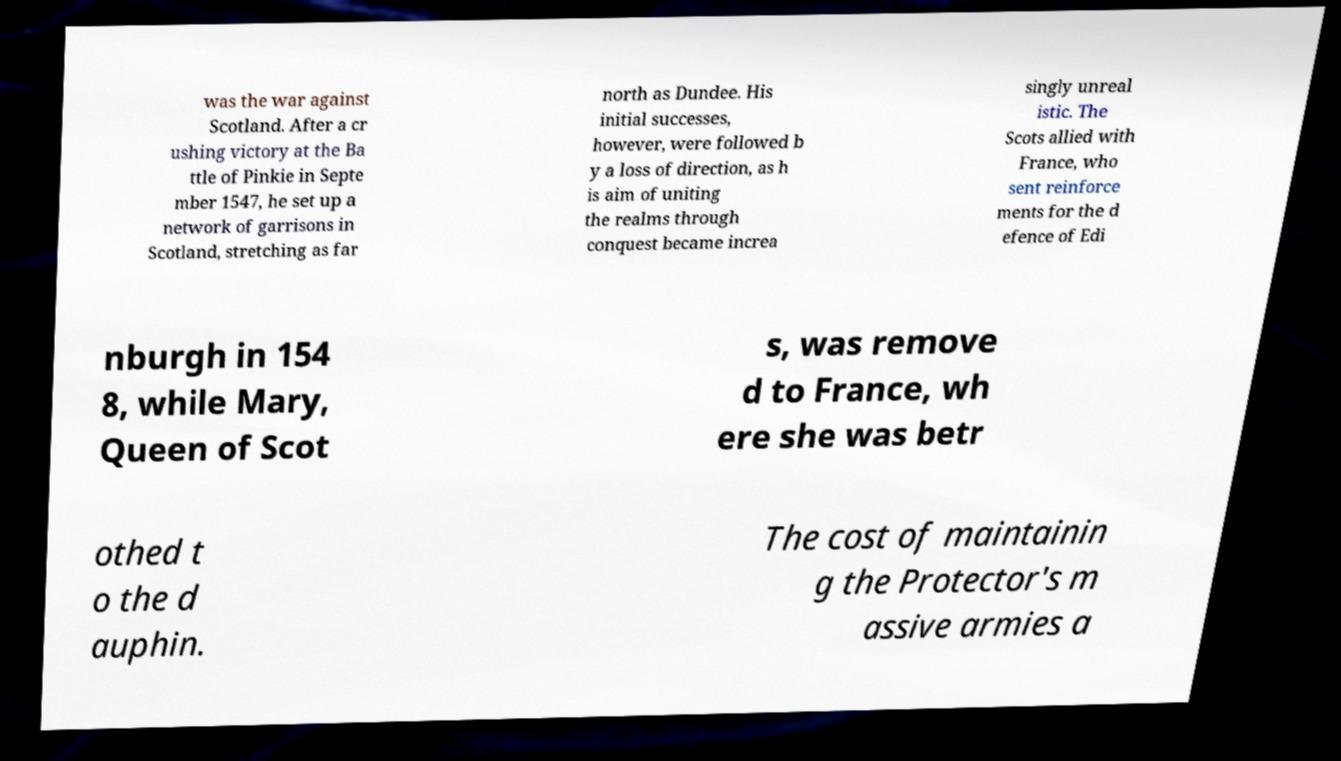Can you read and provide the text displayed in the image?This photo seems to have some interesting text. Can you extract and type it out for me? was the war against Scotland. After a cr ushing victory at the Ba ttle of Pinkie in Septe mber 1547, he set up a network of garrisons in Scotland, stretching as far north as Dundee. His initial successes, however, were followed b y a loss of direction, as h is aim of uniting the realms through conquest became increa singly unreal istic. The Scots allied with France, who sent reinforce ments for the d efence of Edi nburgh in 154 8, while Mary, Queen of Scot s, was remove d to France, wh ere she was betr othed t o the d auphin. The cost of maintainin g the Protector's m assive armies a 